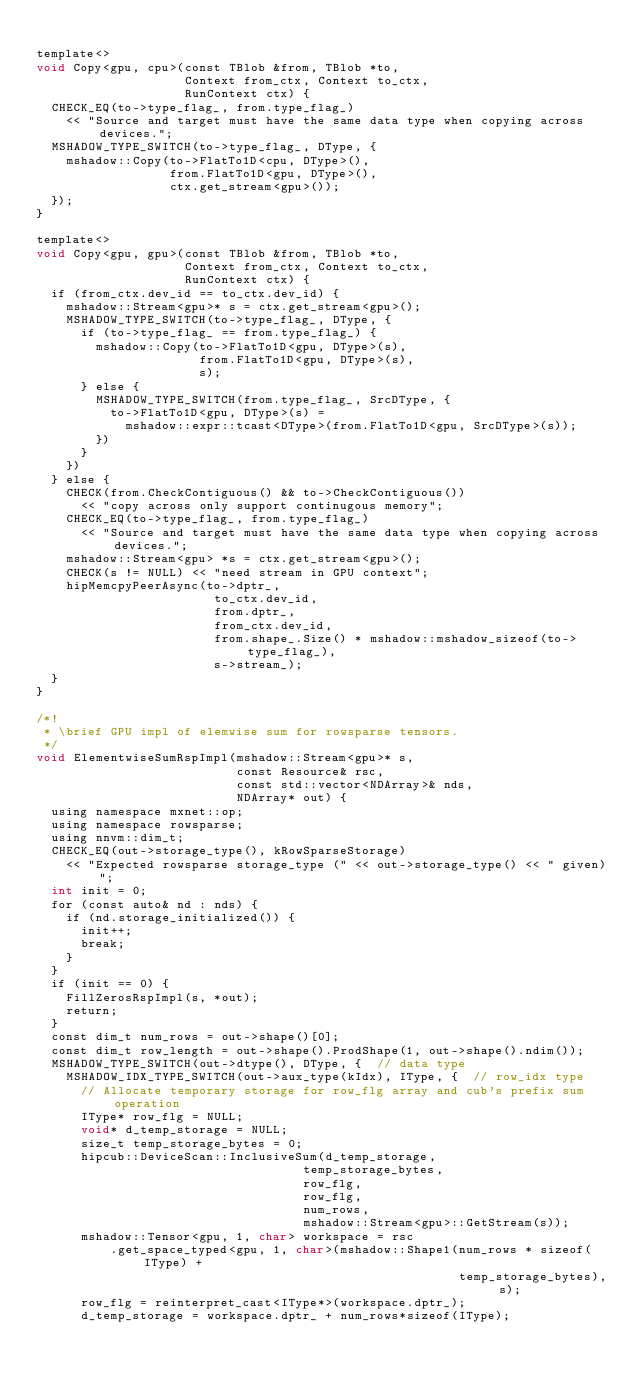<code> <loc_0><loc_0><loc_500><loc_500><_Cuda_>
template<>
void Copy<gpu, cpu>(const TBlob &from, TBlob *to,
                    Context from_ctx, Context to_ctx,
                    RunContext ctx) {
  CHECK_EQ(to->type_flag_, from.type_flag_)
    << "Source and target must have the same data type when copying across devices.";
  MSHADOW_TYPE_SWITCH(to->type_flag_, DType, {
    mshadow::Copy(to->FlatTo1D<cpu, DType>(),
                  from.FlatTo1D<gpu, DType>(),
                  ctx.get_stream<gpu>());
  });
}

template<>
void Copy<gpu, gpu>(const TBlob &from, TBlob *to,
                    Context from_ctx, Context to_ctx,
                    RunContext ctx) {
  if (from_ctx.dev_id == to_ctx.dev_id) {
    mshadow::Stream<gpu>* s = ctx.get_stream<gpu>();
    MSHADOW_TYPE_SWITCH(to->type_flag_, DType, {
      if (to->type_flag_ == from.type_flag_) {
        mshadow::Copy(to->FlatTo1D<gpu, DType>(s),
                      from.FlatTo1D<gpu, DType>(s),
                      s);
      } else {
        MSHADOW_TYPE_SWITCH(from.type_flag_, SrcDType, {
          to->FlatTo1D<gpu, DType>(s) =
            mshadow::expr::tcast<DType>(from.FlatTo1D<gpu, SrcDType>(s));
        })
      }
    })
  } else {
    CHECK(from.CheckContiguous() && to->CheckContiguous())
      << "copy across only support continugous memory";
    CHECK_EQ(to->type_flag_, from.type_flag_)
      << "Source and target must have the same data type when copying across devices.";
    mshadow::Stream<gpu> *s = ctx.get_stream<gpu>();
    CHECK(s != NULL) << "need stream in GPU context";
    hipMemcpyPeerAsync(to->dptr_,
                        to_ctx.dev_id,
                        from.dptr_,
                        from_ctx.dev_id,
                        from.shape_.Size() * mshadow::mshadow_sizeof(to->type_flag_),
                        s->stream_);
  }
}

/*!
 * \brief GPU impl of elemwise sum for rowsparse tensors.
 */
void ElementwiseSumRspImpl(mshadow::Stream<gpu>* s,
                           const Resource& rsc,
                           const std::vector<NDArray>& nds,
                           NDArray* out) {
  using namespace mxnet::op;
  using namespace rowsparse;
  using nnvm::dim_t;
  CHECK_EQ(out->storage_type(), kRowSparseStorage)
    << "Expected rowsparse storage_type (" << out->storage_type() << " given)";
  int init = 0;
  for (const auto& nd : nds) {
    if (nd.storage_initialized()) {
      init++;
      break;
    }
  }
  if (init == 0) {
    FillZerosRspImpl(s, *out);
    return;
  }
  const dim_t num_rows = out->shape()[0];
  const dim_t row_length = out->shape().ProdShape(1, out->shape().ndim());
  MSHADOW_TYPE_SWITCH(out->dtype(), DType, {  // data type
    MSHADOW_IDX_TYPE_SWITCH(out->aux_type(kIdx), IType, {  // row_idx type
      // Allocate temporary storage for row_flg array and cub's prefix sum operation
      IType* row_flg = NULL;
      void* d_temp_storage = NULL;
      size_t temp_storage_bytes = 0;
      hipcub::DeviceScan::InclusiveSum(d_temp_storage,
                                    temp_storage_bytes,
                                    row_flg,
                                    row_flg,
                                    num_rows,
                                    mshadow::Stream<gpu>::GetStream(s));
      mshadow::Tensor<gpu, 1, char> workspace = rsc
          .get_space_typed<gpu, 1, char>(mshadow::Shape1(num_rows * sizeof(IType) +
                                                         temp_storage_bytes), s);
      row_flg = reinterpret_cast<IType*>(workspace.dptr_);
      d_temp_storage = workspace.dptr_ + num_rows*sizeof(IType);</code> 